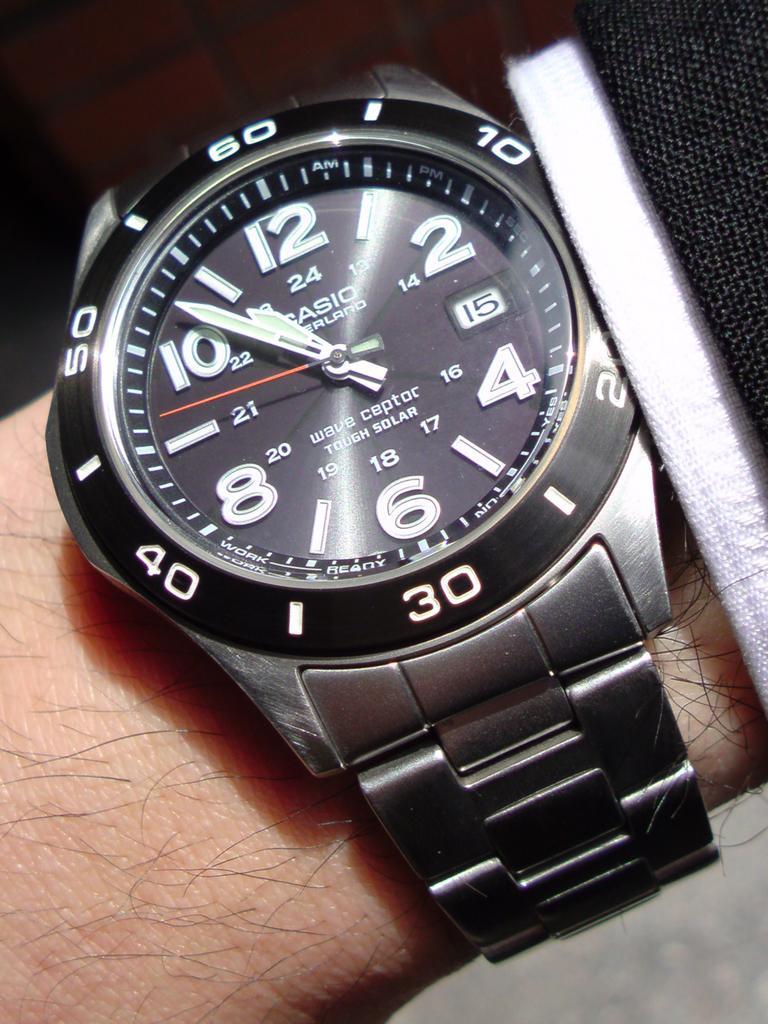In one or two sentences, can you explain what this image depicts? In this image I can see a human hand and I can also see a watch which is in gray color. 